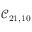<formula> <loc_0><loc_0><loc_500><loc_500>\mathcal { C } _ { 2 1 , 1 0 }</formula> 